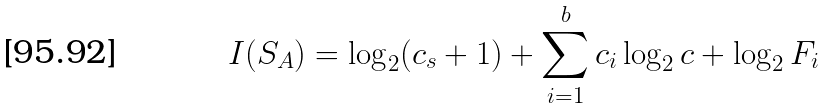Convert formula to latex. <formula><loc_0><loc_0><loc_500><loc_500>I ( S _ { A } ) = \log _ { 2 } ( c _ { s } + 1 ) + \sum _ { i = 1 } ^ { b } c _ { i } \log _ { 2 } c + \log _ { 2 } F _ { i }</formula> 